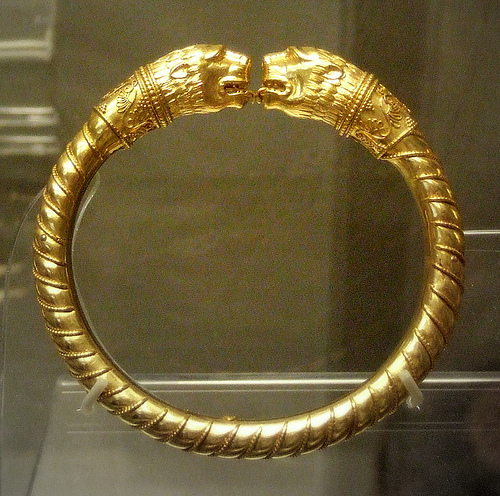<image>
Can you confirm if the lion is on the ring? Yes. Looking at the image, I can see the lion is positioned on top of the ring, with the ring providing support. 